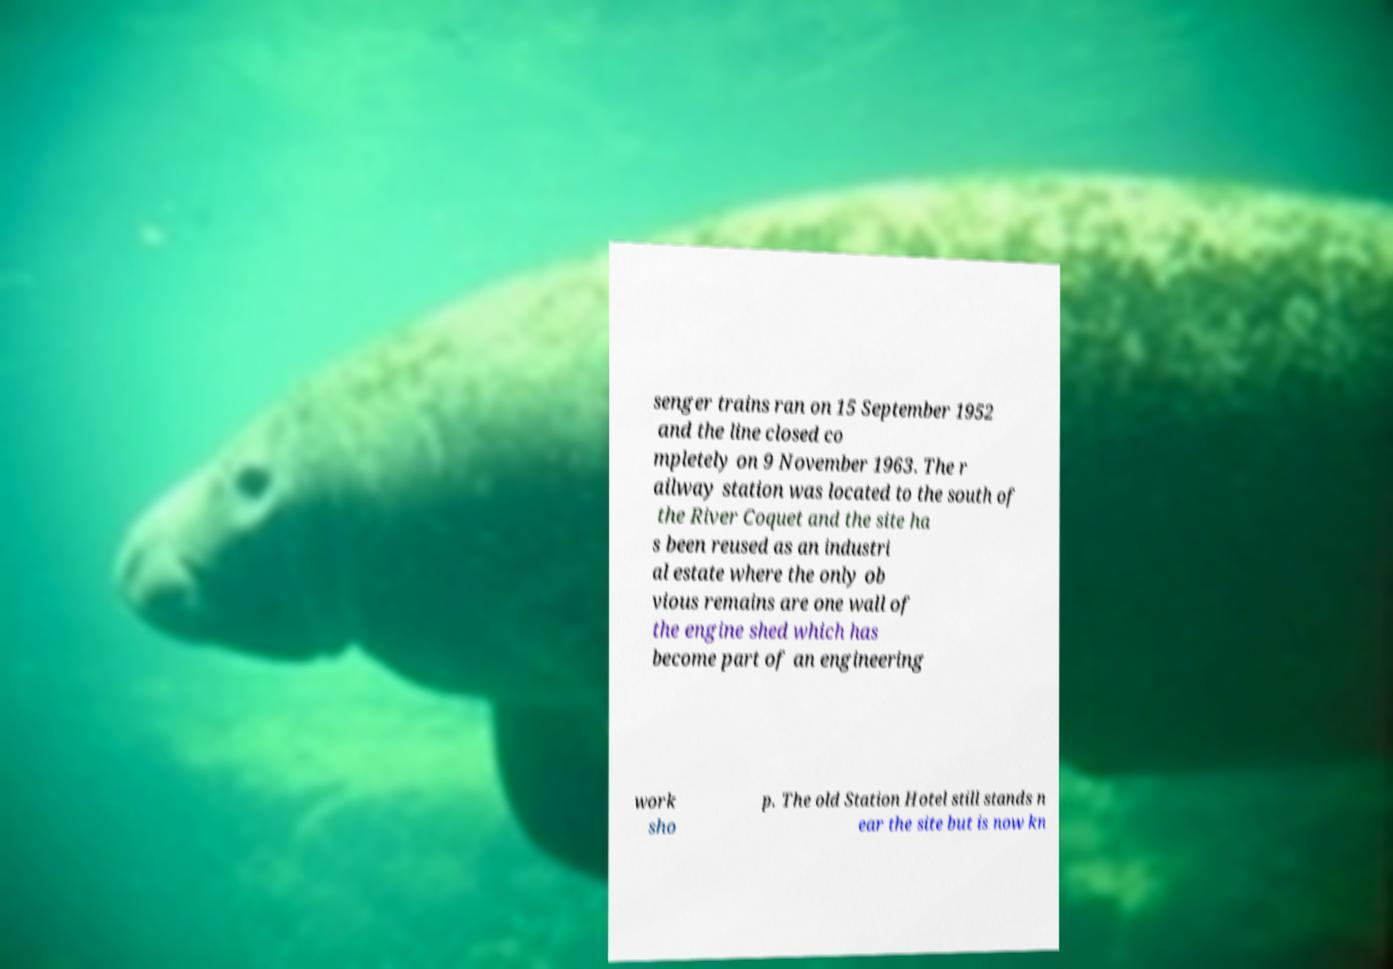What messages or text are displayed in this image? I need them in a readable, typed format. senger trains ran on 15 September 1952 and the line closed co mpletely on 9 November 1963. The r ailway station was located to the south of the River Coquet and the site ha s been reused as an industri al estate where the only ob vious remains are one wall of the engine shed which has become part of an engineering work sho p. The old Station Hotel still stands n ear the site but is now kn 